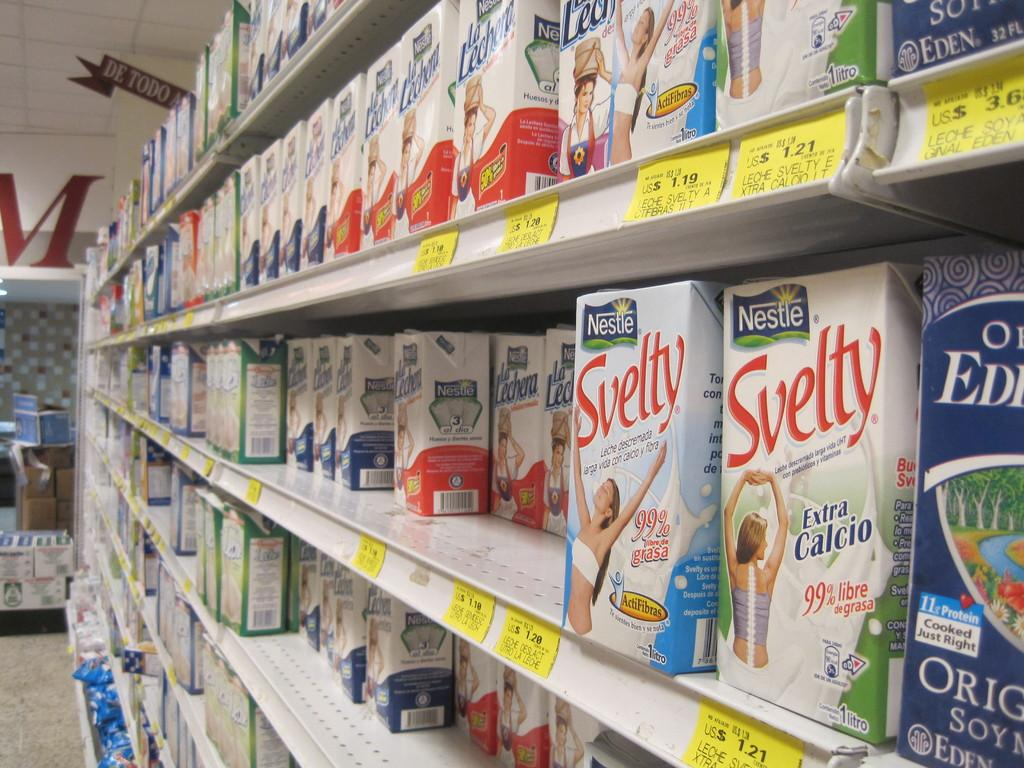<image>
Present a compact description of the photo's key features. On a store shelf sits cartons of Nestle Svelty. 